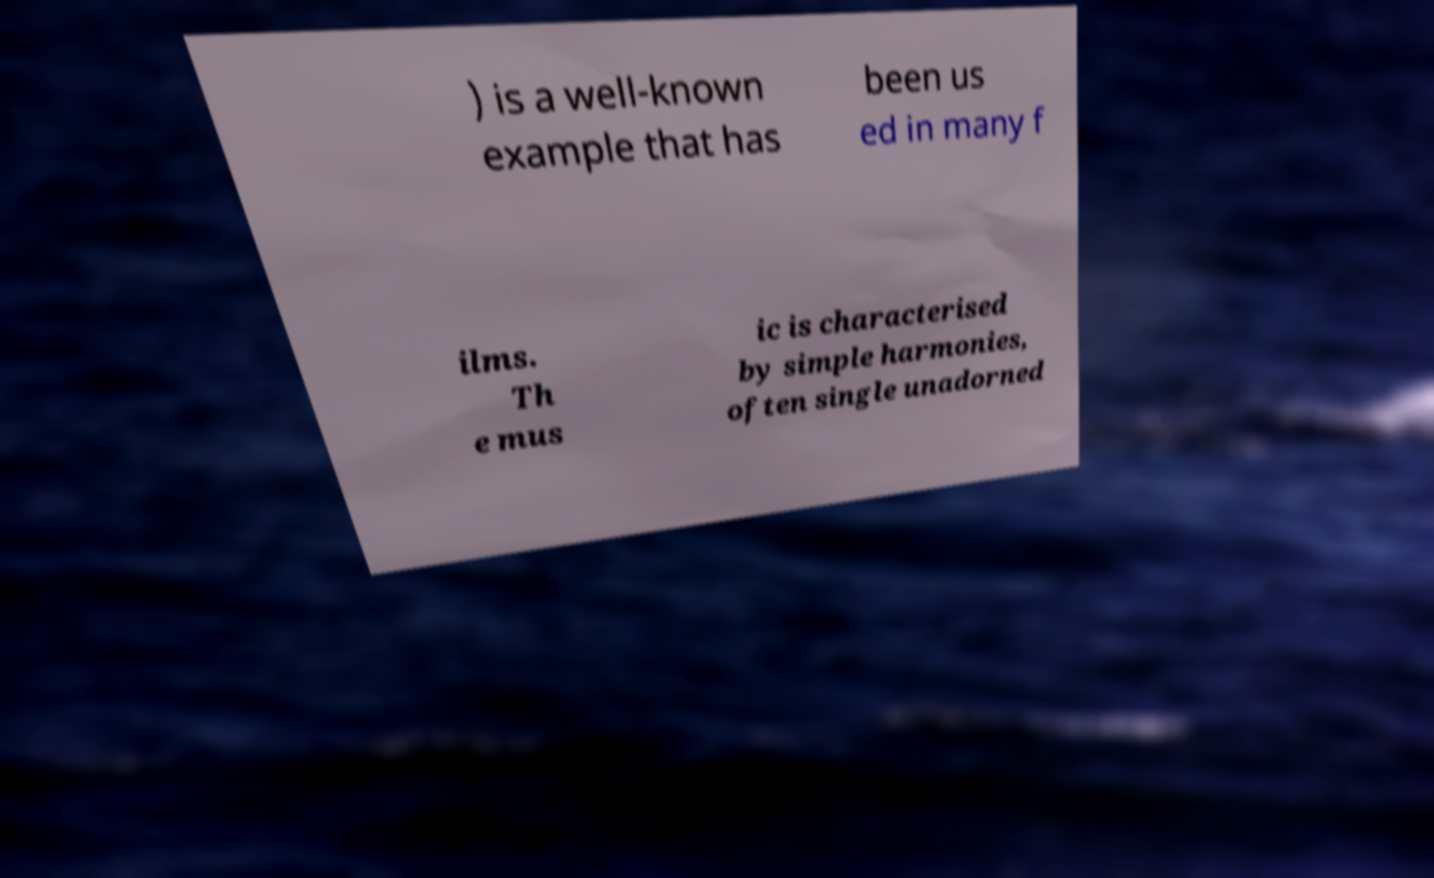Could you extract and type out the text from this image? ) is a well-known example that has been us ed in many f ilms. Th e mus ic is characterised by simple harmonies, often single unadorned 